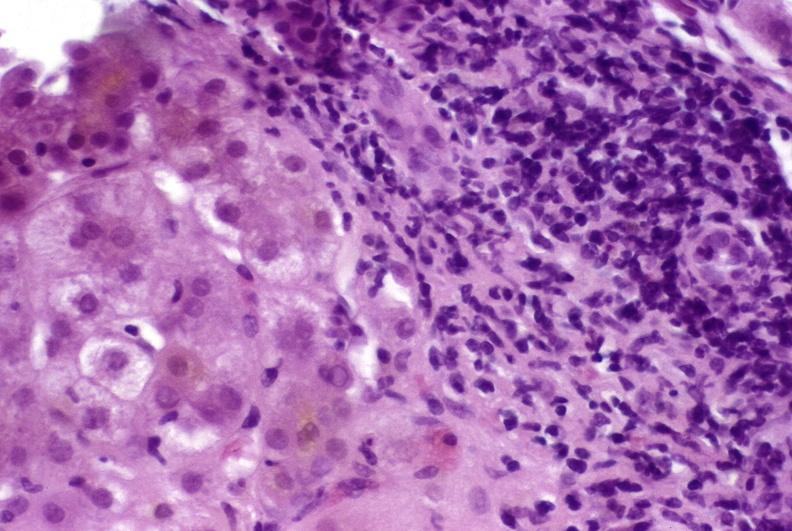s liver present?
Answer the question using a single word or phrase. Yes 